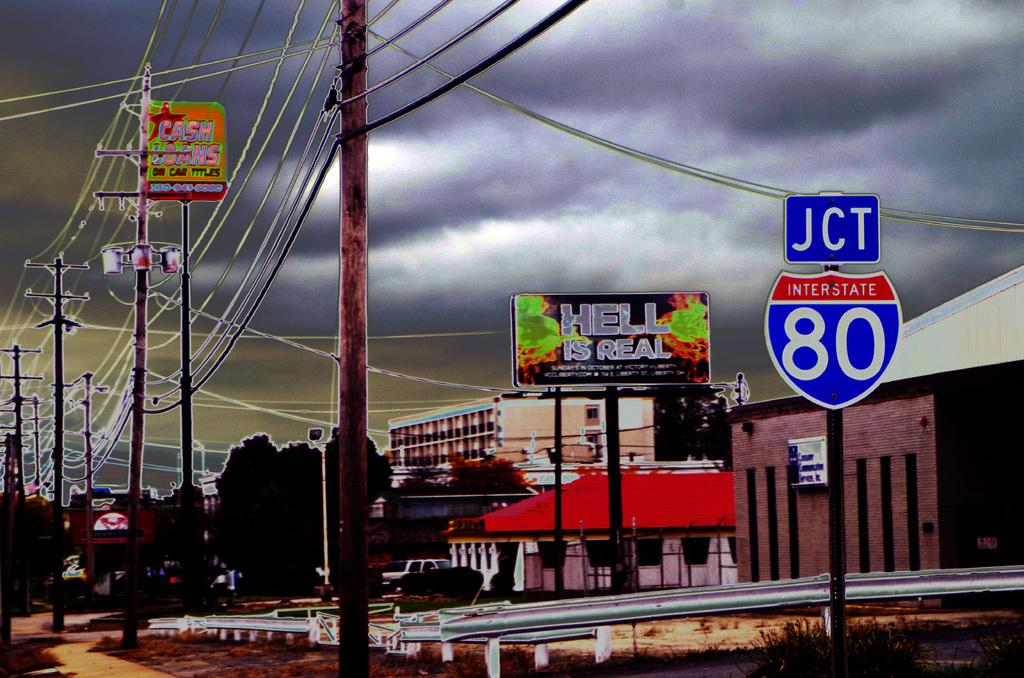<image>
Render a clear and concise summary of the photo. a road sign that is blue and red and says 'jct interstate 80' on it 